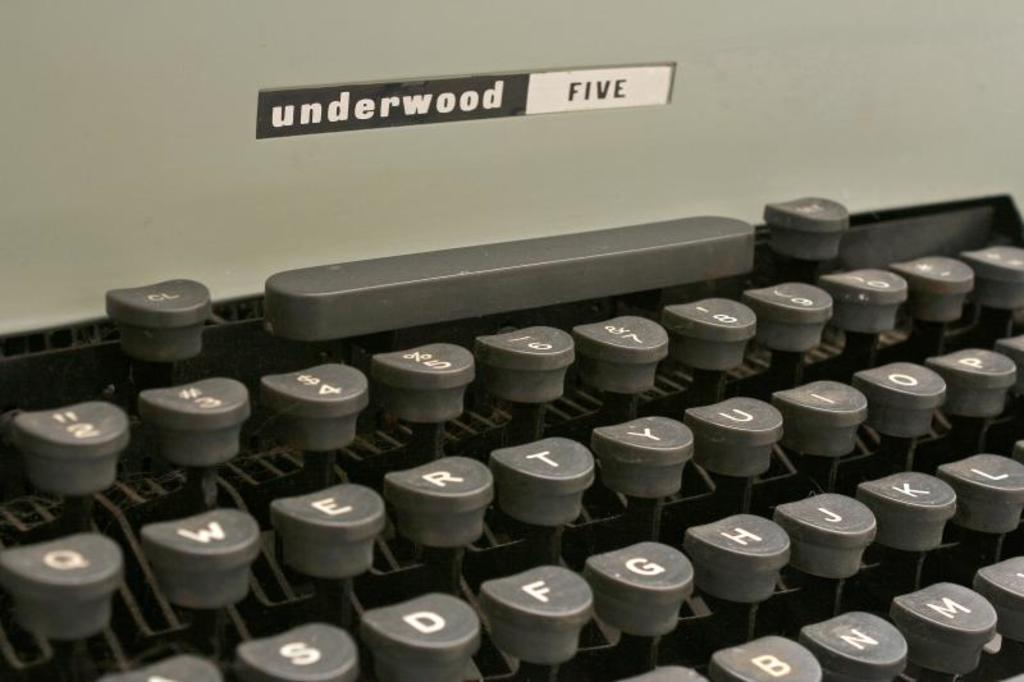<image>
Summarize the visual content of the image. close up of underwood five typewriter showing part of several rows of keys 